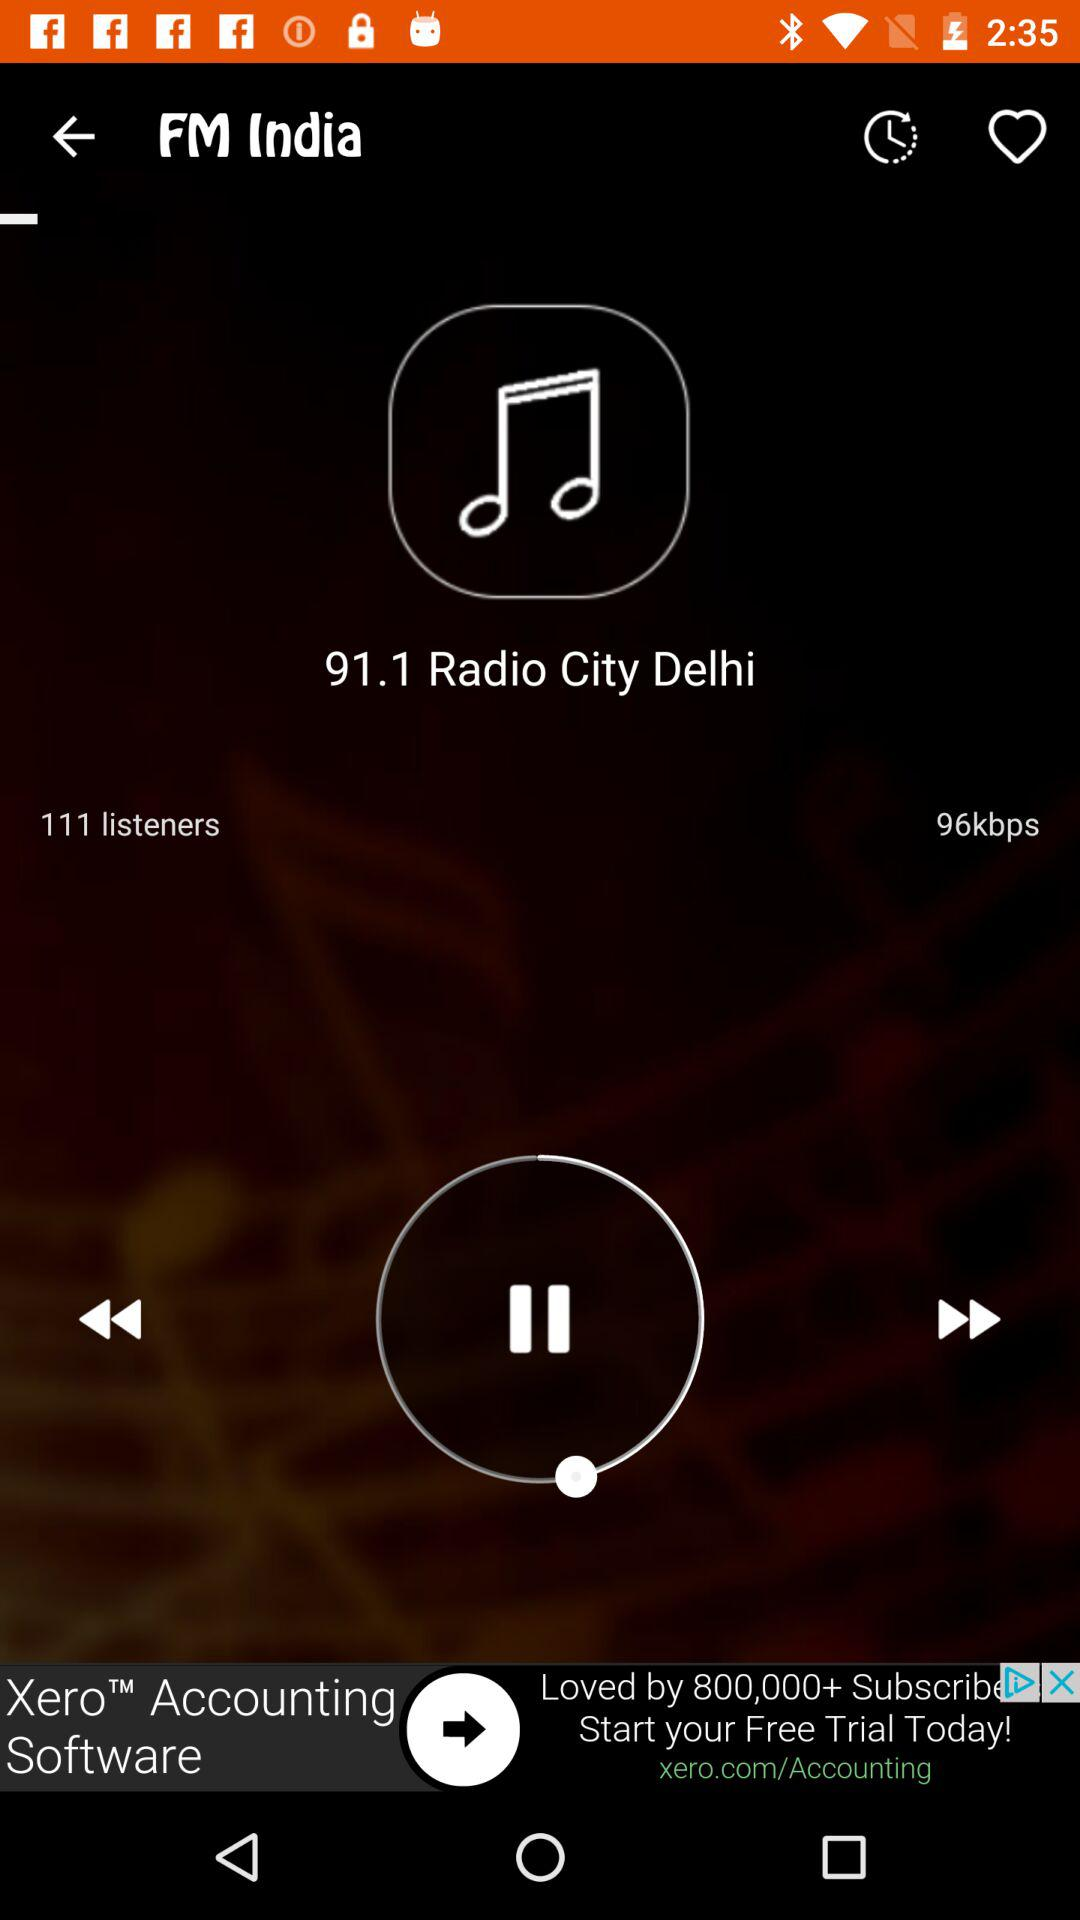How many listeners are there? There are 111 listeners. 